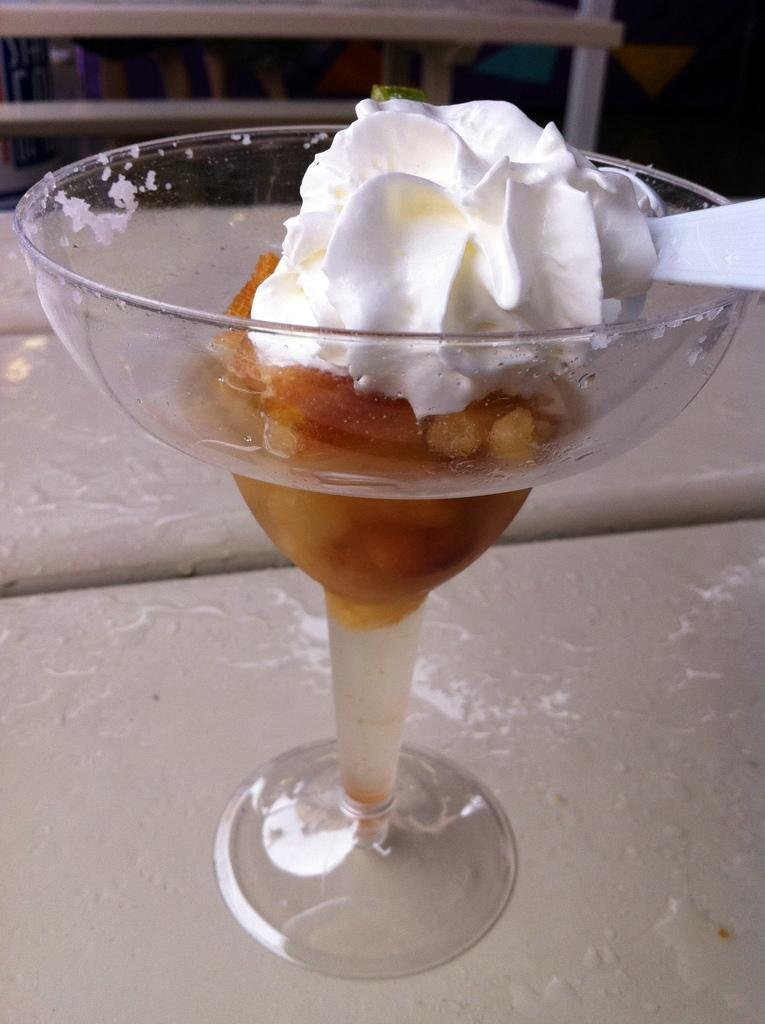What is the main subject of the image? The main subject of the image is an ice cream. What utensil is present in the image? There is a white-colored spoon in the image. Where is the toothbrush located in the image? There is no toothbrush present in the image. What type of doctor is standing next to the ice cream in the image? There is no doctor present in the image. 